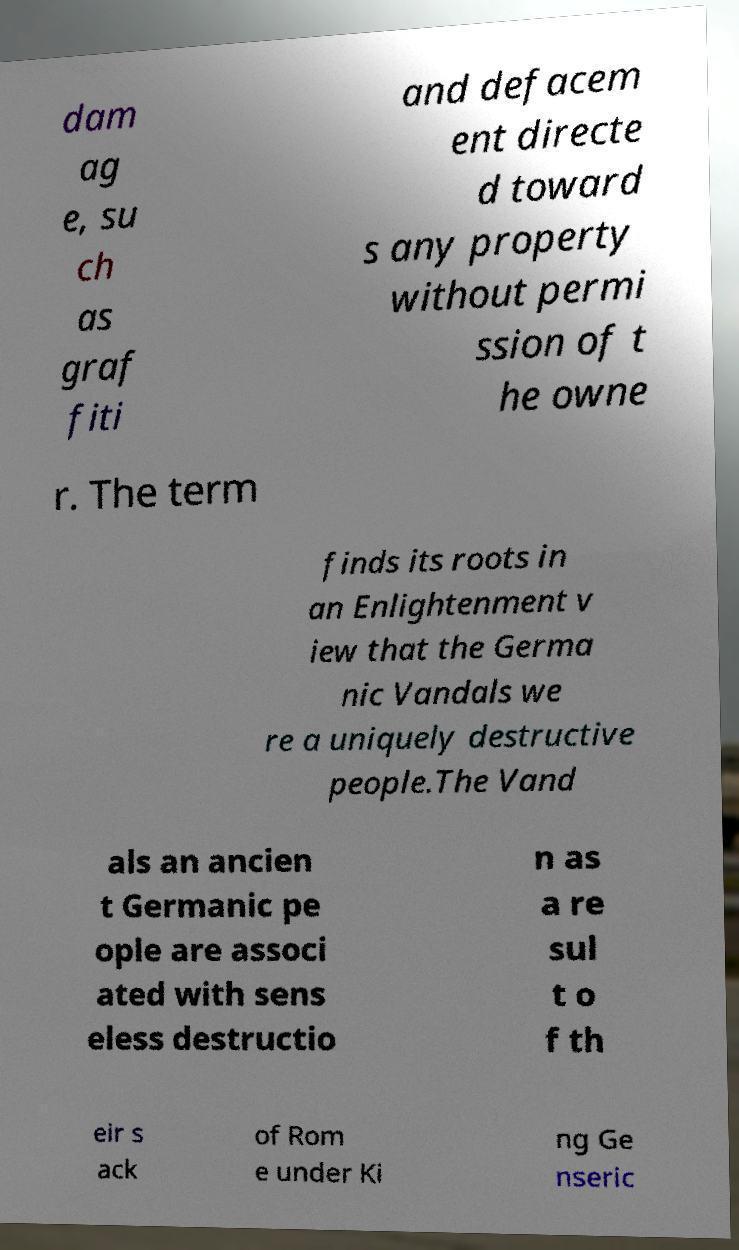Could you assist in decoding the text presented in this image and type it out clearly? dam ag e, su ch as graf fiti and defacem ent directe d toward s any property without permi ssion of t he owne r. The term finds its roots in an Enlightenment v iew that the Germa nic Vandals we re a uniquely destructive people.The Vand als an ancien t Germanic pe ople are associ ated with sens eless destructio n as a re sul t o f th eir s ack of Rom e under Ki ng Ge nseric 